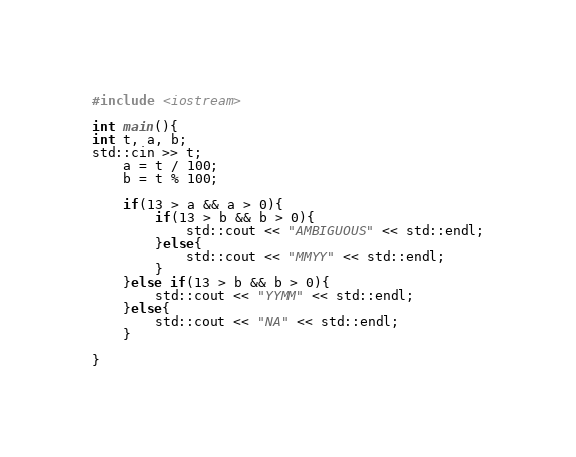Convert code to text. <code><loc_0><loc_0><loc_500><loc_500><_C++_>#include <iostream>

int main(){
int t, a, b;
std::cin >> t;
    a = t / 100;
    b = t % 100;

    if(13 > a && a > 0){
        if(13 > b && b > 0){
            std::cout << "AMBIGUOUS" << std::endl;
        }else{
            std::cout << "MMYY" << std::endl;
        }
    }else if(13 > b && b > 0){
        std::cout << "YYMM" << std::endl;
    }else{
        std::cout << "NA" << std::endl;
    }

}</code> 